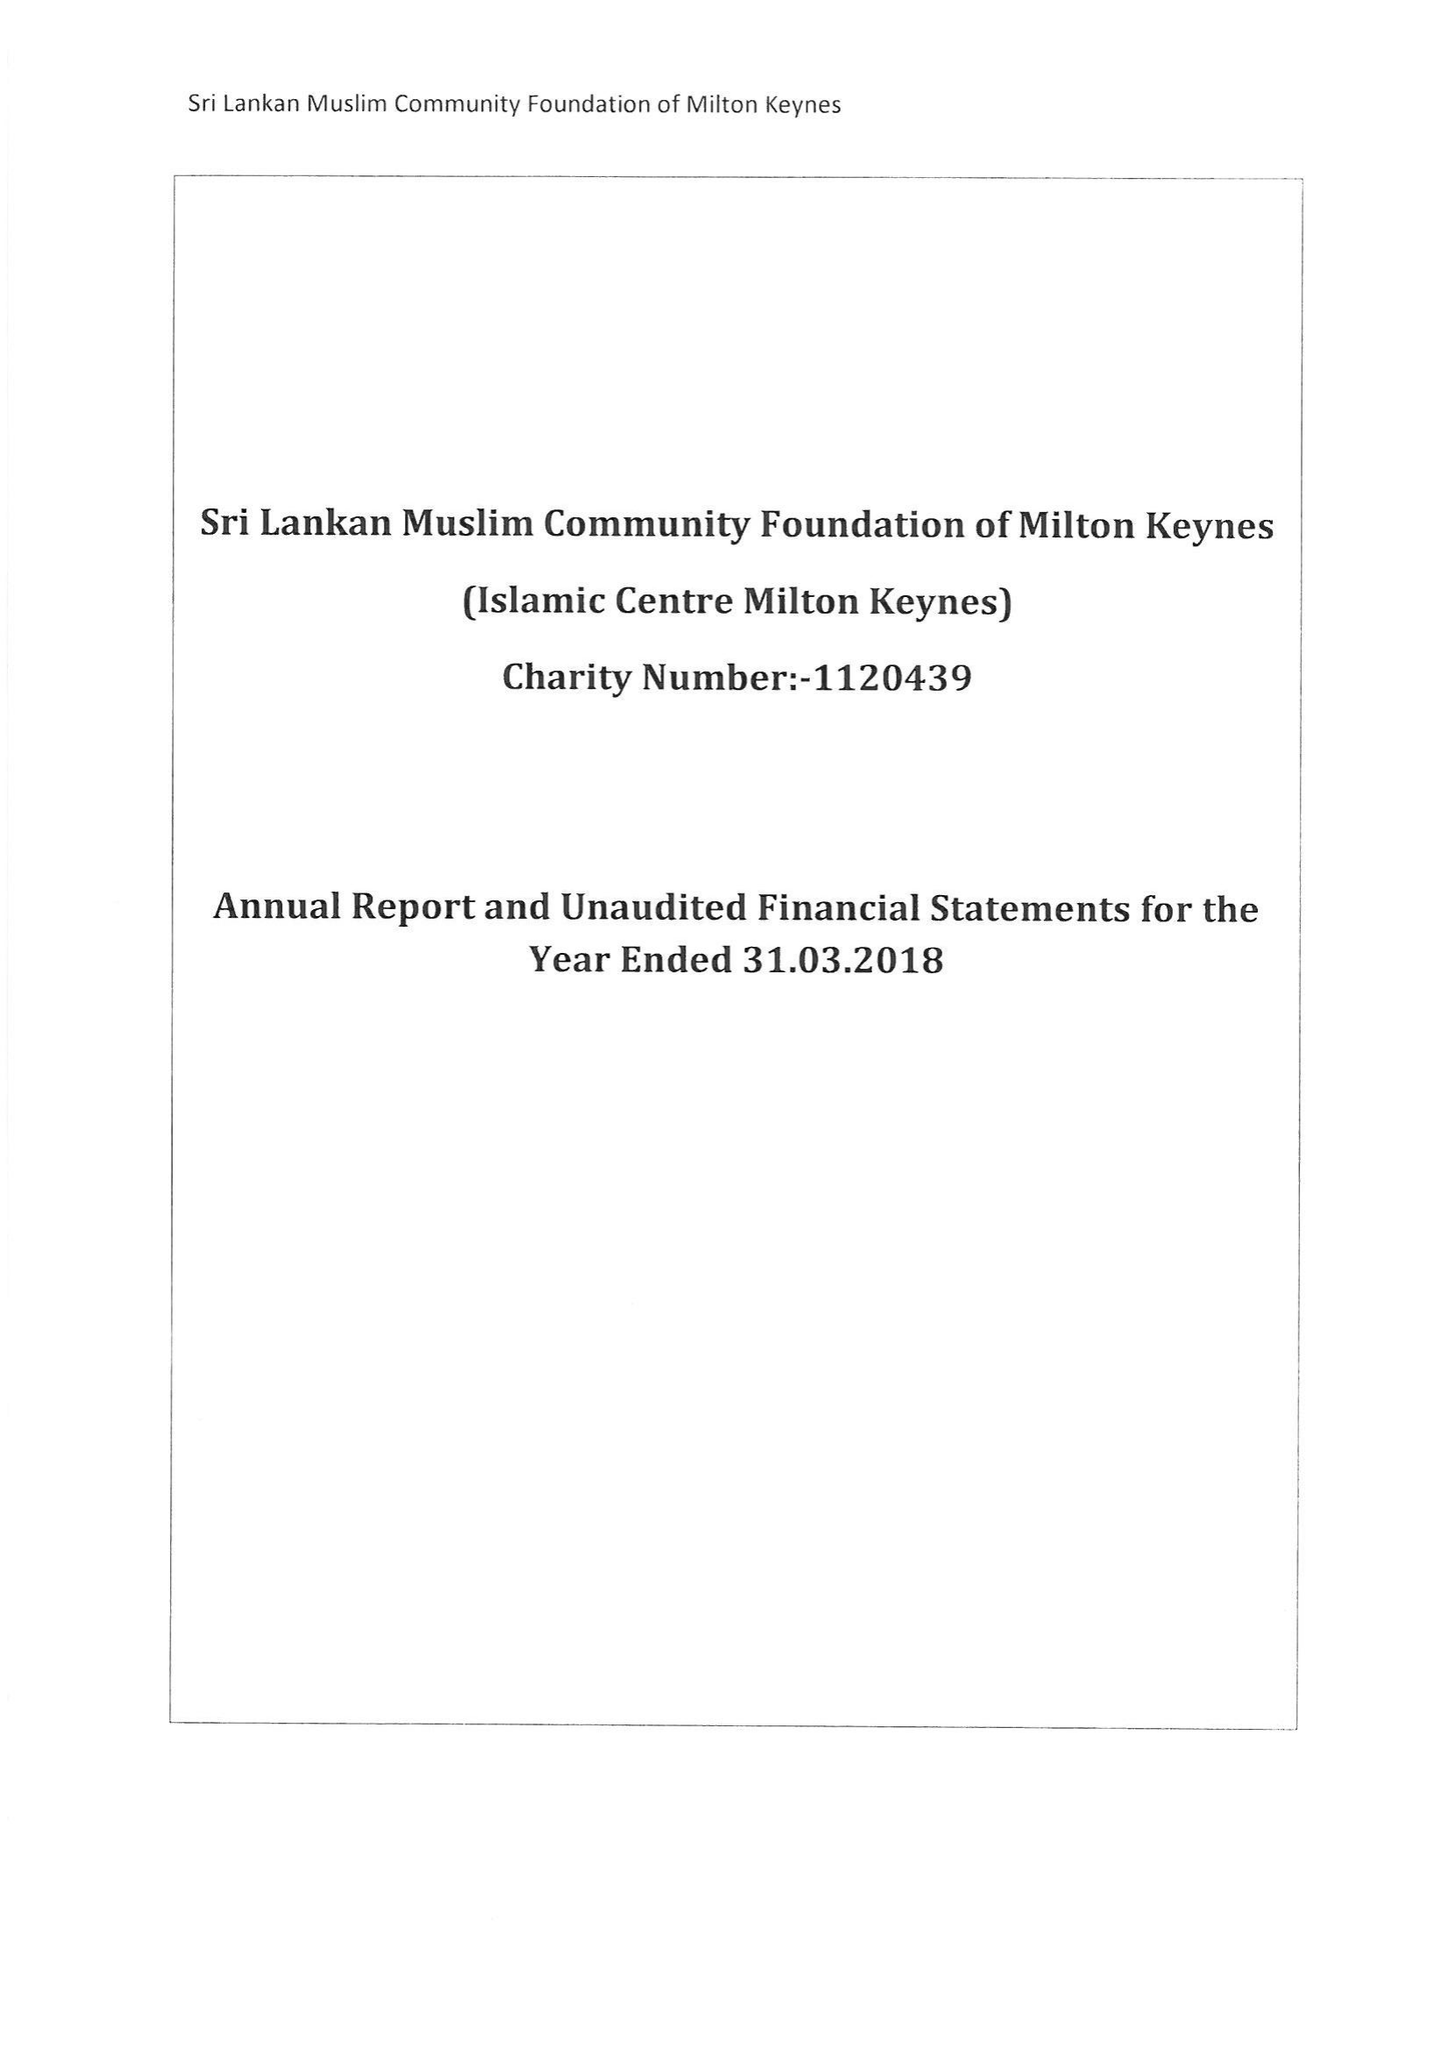What is the value for the address__postcode?
Answer the question using a single word or phrase. MK6 2AQ 